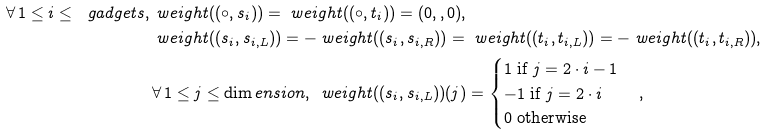Convert formula to latex. <formula><loc_0><loc_0><loc_500><loc_500>\forall \, 1 \leq i \leq \ g a d g e t s , \, & \ w e i g h t ( ( \circ , s _ { i } ) ) = \ w e i g h t ( ( \circ , t _ { i } ) ) = ( 0 , , 0 ) , \\ & \ w e i g h t ( ( s _ { i } , s _ { i , L } ) ) = - \ w e i g h t ( ( s _ { i } , s _ { i , R } ) ) = \ w e i g h t ( ( t _ { i } , t _ { i , L } ) ) = - \ w e i g h t ( ( t _ { i } , t _ { i , R } ) ) , \\ & \forall \, 1 \leq j \leq \dim e n s i o n , \, \ w e i g h t ( ( s _ { i } , s _ { i , L } ) ) ( j ) = \begin{cases} 1 \text { if } j = 2 \cdot i - 1 \\ - 1 \text { if } j = 2 \cdot i \\ 0 \text { otherwise} \end{cases} ,</formula> 